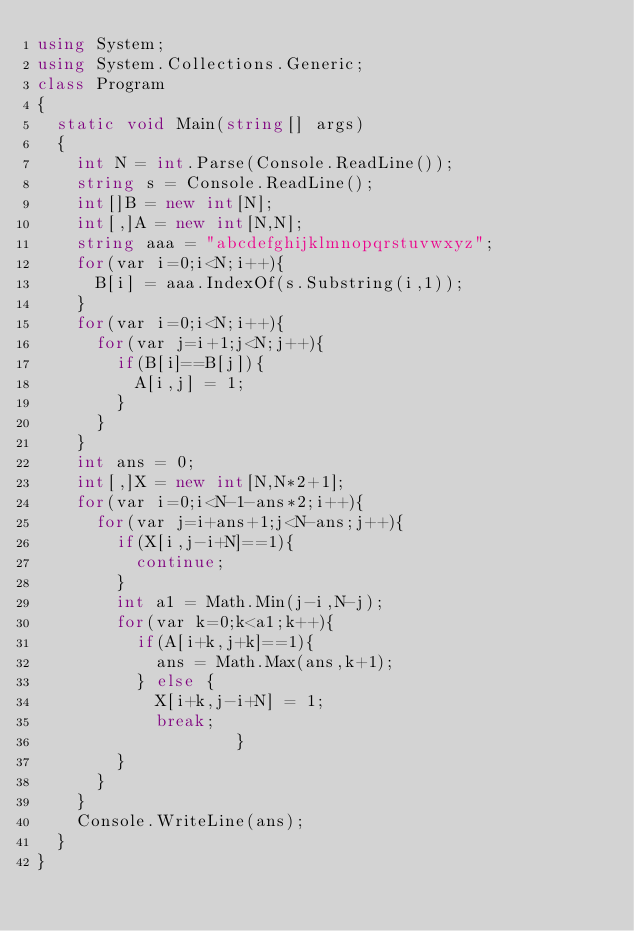<code> <loc_0><loc_0><loc_500><loc_500><_C#_>using System;
using System.Collections.Generic;
class Program
{
	static void Main(string[] args)
	{
		int N = int.Parse(Console.ReadLine());
		string s = Console.ReadLine();
		int[]B = new int[N];
		int[,]A = new int[N,N];
		string aaa = "abcdefghijklmnopqrstuvwxyz";
		for(var i=0;i<N;i++){
			B[i] = aaa.IndexOf(s.Substring(i,1));
		}
		for(var i=0;i<N;i++){
			for(var j=i+1;j<N;j++){
				if(B[i]==B[j]){
					A[i,j] = 1;
				}
			}
		}
		int ans = 0;
		int[,]X = new int[N,N*2+1];
		for(var i=0;i<N-1-ans*2;i++){
			for(var j=i+ans+1;j<N-ans;j++){
				if(X[i,j-i+N]==1){
					continue;
				}
				int a1 = Math.Min(j-i,N-j);
				for(var k=0;k<a1;k++){
					if(A[i+k,j+k]==1){
						ans = Math.Max(ans,k+1);
					} else {
						X[i+k,j-i+N] = 1;
						break;
                    }
				}
			}
		}
		Console.WriteLine(ans);
	}
}</code> 